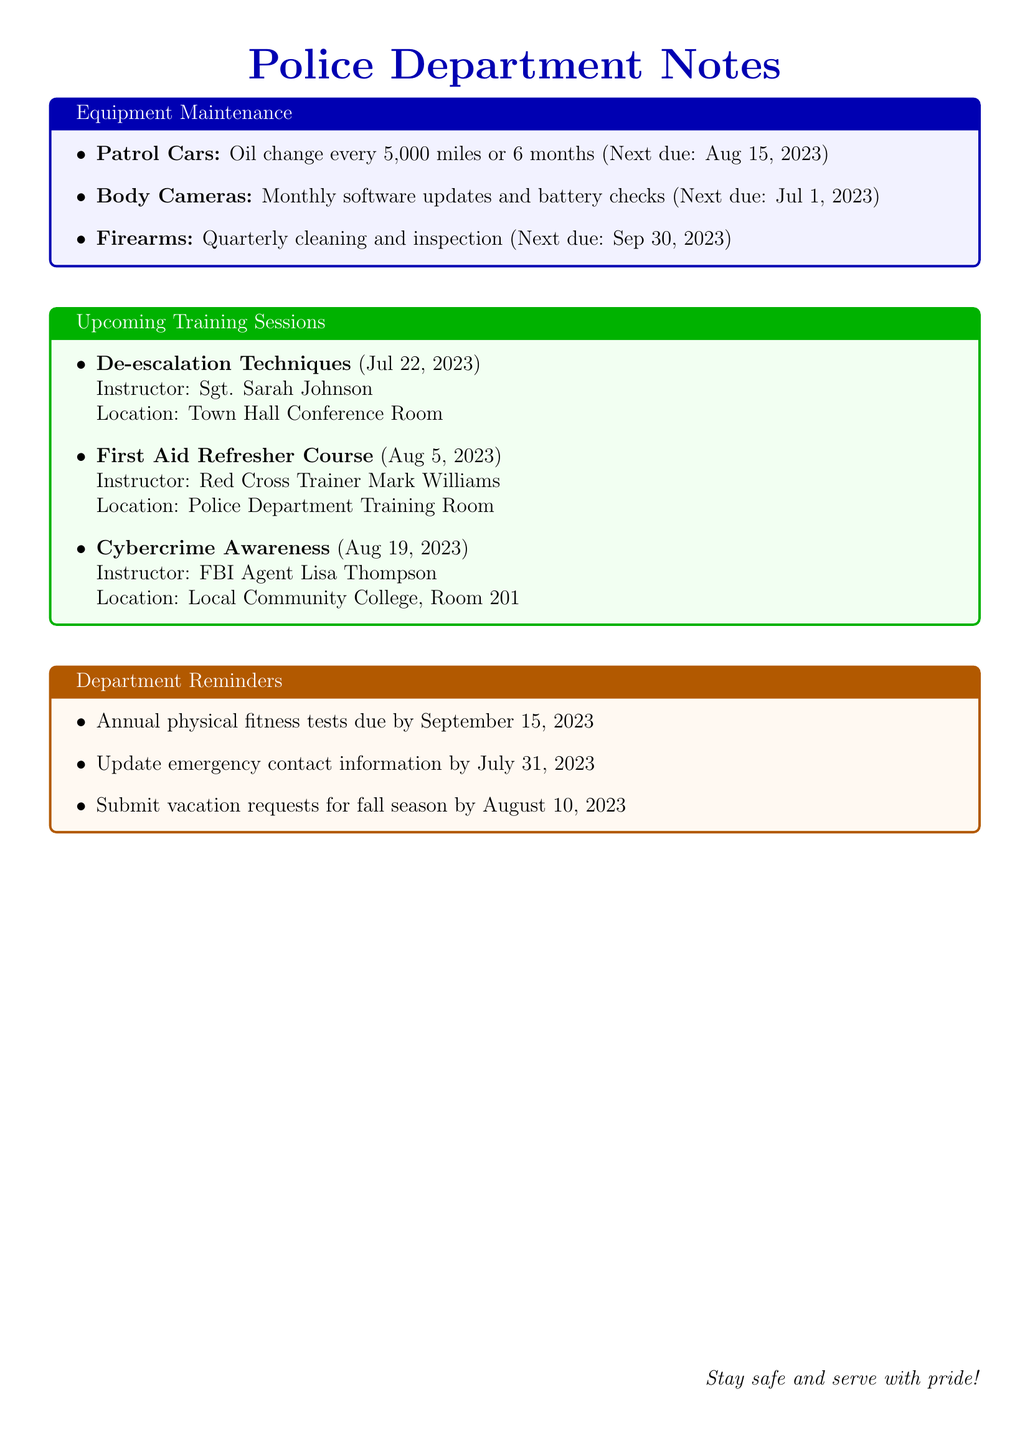What is the next due date for the patrol cars' oil change? The next due date for the patrol cars' oil change is clearly stated in the maintenance schedule section.
Answer: August 15, 2023 Who is the instructor for the First Aid Refresher Course? The instructor for the First Aid Refresher Course is specified in the upcoming training sessions section.
Answer: Red Cross Trainer Mark Williams When is the update for emergency contact information due? This due date is mentioned in the department reminders section.
Answer: July 31, 2023 How often are firearms supposed to be cleaned and inspected? The frequency of firearms maintenance is stated in the equipment maintenance section.
Answer: Quarterly Where will the Cybercrime Awareness training be held? The location for the Cybercrime Awareness training is mentioned in the upcoming training sessions section.
Answer: Local Community College, Room 201 What is the last date to submit vacation requests for the fall season? This deadline is provided in the department reminders section.
Answer: August 10, 2023 What topic is scheduled for July 22, 2023? The topic scheduled for that date is listed in the upcoming training sessions section.
Answer: De-escalation Techniques When is the next scheduled software check for the body cameras? This is specified in the maintenance schedule for body cameras within the equipment maintenance section.
Answer: July 1, 2023 When is the annual physical fitness test due? This date is mentioned in the department reminders section of the document.
Answer: September 15, 2023 